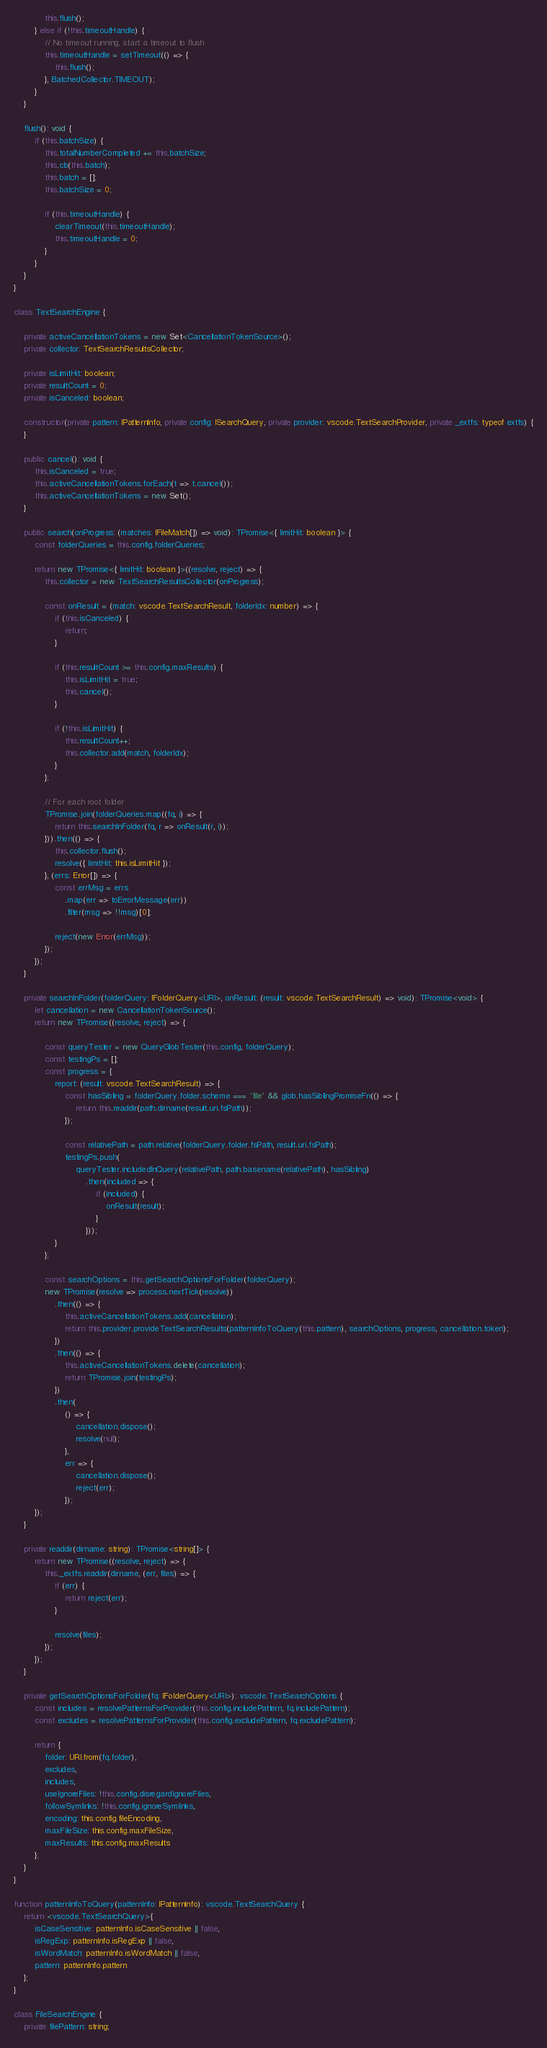Convert code to text. <code><loc_0><loc_0><loc_500><loc_500><_TypeScript_>			this.flush();
		} else if (!this.timeoutHandle) {
			// No timeout running, start a timeout to flush
			this.timeoutHandle = setTimeout(() => {
				this.flush();
			}, BatchedCollector.TIMEOUT);
		}
	}

	flush(): void {
		if (this.batchSize) {
			this.totalNumberCompleted += this.batchSize;
			this.cb(this.batch);
			this.batch = [];
			this.batchSize = 0;

			if (this.timeoutHandle) {
				clearTimeout(this.timeoutHandle);
				this.timeoutHandle = 0;
			}
		}
	}
}

class TextSearchEngine {

	private activeCancellationTokens = new Set<CancellationTokenSource>();
	private collector: TextSearchResultsCollector;

	private isLimitHit: boolean;
	private resultCount = 0;
	private isCanceled: boolean;

	constructor(private pattern: IPatternInfo, private config: ISearchQuery, private provider: vscode.TextSearchProvider, private _extfs: typeof extfs) {
	}

	public cancel(): void {
		this.isCanceled = true;
		this.activeCancellationTokens.forEach(t => t.cancel());
		this.activeCancellationTokens = new Set();
	}

	public search(onProgress: (matches: IFileMatch[]) => void): TPromise<{ limitHit: boolean }> {
		const folderQueries = this.config.folderQueries;

		return new TPromise<{ limitHit: boolean }>((resolve, reject) => {
			this.collector = new TextSearchResultsCollector(onProgress);

			const onResult = (match: vscode.TextSearchResult, folderIdx: number) => {
				if (this.isCanceled) {
					return;
				}

				if (this.resultCount >= this.config.maxResults) {
					this.isLimitHit = true;
					this.cancel();
				}

				if (!this.isLimitHit) {
					this.resultCount++;
					this.collector.add(match, folderIdx);
				}
			};

			// For each root folder
			TPromise.join(folderQueries.map((fq, i) => {
				return this.searchInFolder(fq, r => onResult(r, i));
			})).then(() => {
				this.collector.flush();
				resolve({ limitHit: this.isLimitHit });
			}, (errs: Error[]) => {
				const errMsg = errs
					.map(err => toErrorMessage(err))
					.filter(msg => !!msg)[0];

				reject(new Error(errMsg));
			});
		});
	}

	private searchInFolder(folderQuery: IFolderQuery<URI>, onResult: (result: vscode.TextSearchResult) => void): TPromise<void> {
		let cancellation = new CancellationTokenSource();
		return new TPromise((resolve, reject) => {

			const queryTester = new QueryGlobTester(this.config, folderQuery);
			const testingPs = [];
			const progress = {
				report: (result: vscode.TextSearchResult) => {
					const hasSibling = folderQuery.folder.scheme === 'file' && glob.hasSiblingPromiseFn(() => {
						return this.readdir(path.dirname(result.uri.fsPath));
					});

					const relativePath = path.relative(folderQuery.folder.fsPath, result.uri.fsPath);
					testingPs.push(
						queryTester.includedInQuery(relativePath, path.basename(relativePath), hasSibling)
							.then(included => {
								if (included) {
									onResult(result);
								}
							}));
				}
			};

			const searchOptions = this.getSearchOptionsForFolder(folderQuery);
			new TPromise(resolve => process.nextTick(resolve))
				.then(() => {
					this.activeCancellationTokens.add(cancellation);
					return this.provider.provideTextSearchResults(patternInfoToQuery(this.pattern), searchOptions, progress, cancellation.token);
				})
				.then(() => {
					this.activeCancellationTokens.delete(cancellation);
					return TPromise.join(testingPs);
				})
				.then(
					() => {
						cancellation.dispose();
						resolve(null);
					},
					err => {
						cancellation.dispose();
						reject(err);
					});
		});
	}

	private readdir(dirname: string): TPromise<string[]> {
		return new TPromise((resolve, reject) => {
			this._extfs.readdir(dirname, (err, files) => {
				if (err) {
					return reject(err);
				}

				resolve(files);
			});
		});
	}

	private getSearchOptionsForFolder(fq: IFolderQuery<URI>): vscode.TextSearchOptions {
		const includes = resolvePatternsForProvider(this.config.includePattern, fq.includePattern);
		const excludes = resolvePatternsForProvider(this.config.excludePattern, fq.excludePattern);

		return {
			folder: URI.from(fq.folder),
			excludes,
			includes,
			useIgnoreFiles: !this.config.disregardIgnoreFiles,
			followSymlinks: !this.config.ignoreSymlinks,
			encoding: this.config.fileEncoding,
			maxFileSize: this.config.maxFileSize,
			maxResults: this.config.maxResults
		};
	}
}

function patternInfoToQuery(patternInfo: IPatternInfo): vscode.TextSearchQuery {
	return <vscode.TextSearchQuery>{
		isCaseSensitive: patternInfo.isCaseSensitive || false,
		isRegExp: patternInfo.isRegExp || false,
		isWordMatch: patternInfo.isWordMatch || false,
		pattern: patternInfo.pattern
	};
}

class FileSearchEngine {
	private filePattern: string;</code> 